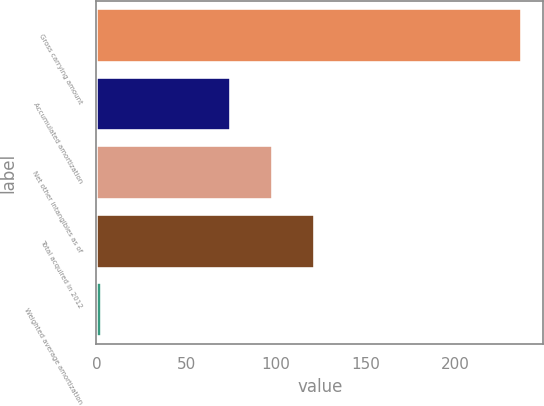Convert chart. <chart><loc_0><loc_0><loc_500><loc_500><bar_chart><fcel>Gross carrying amount<fcel>Accumulated amortization<fcel>Net other intangibles as of<fcel>Total acquired in 2012<fcel>Weighted average amortization<nl><fcel>236.9<fcel>75.1<fcel>98.47<fcel>121.84<fcel>3.25<nl></chart> 